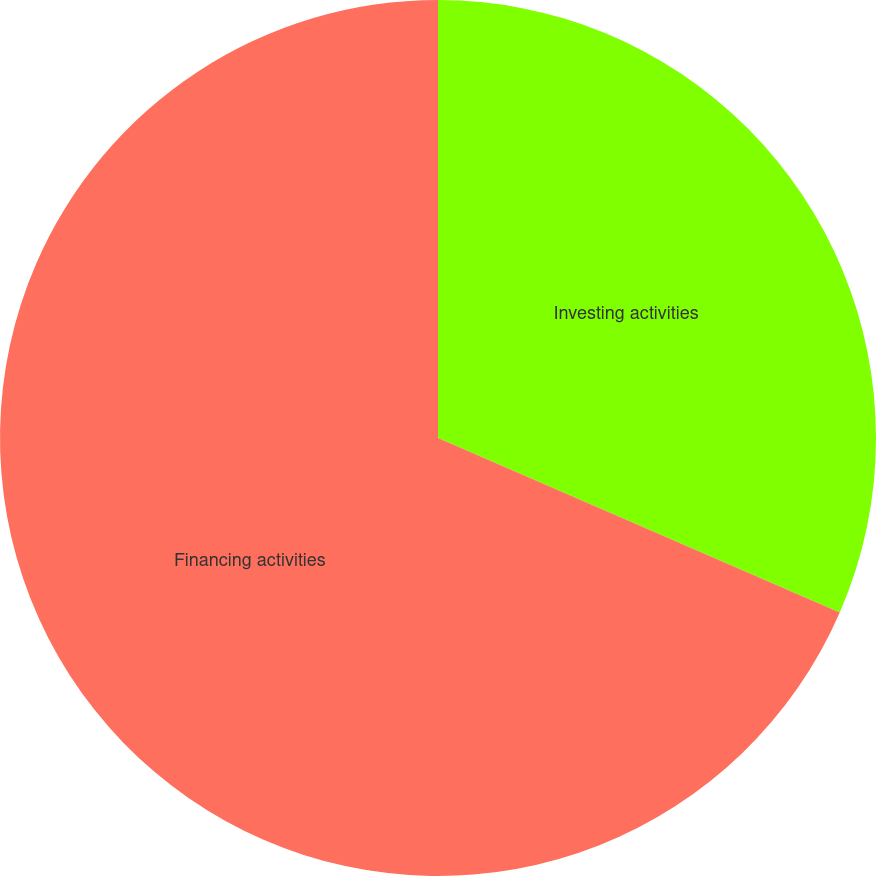Convert chart. <chart><loc_0><loc_0><loc_500><loc_500><pie_chart><fcel>Investing activities<fcel>Financing activities<nl><fcel>31.52%<fcel>68.48%<nl></chart> 